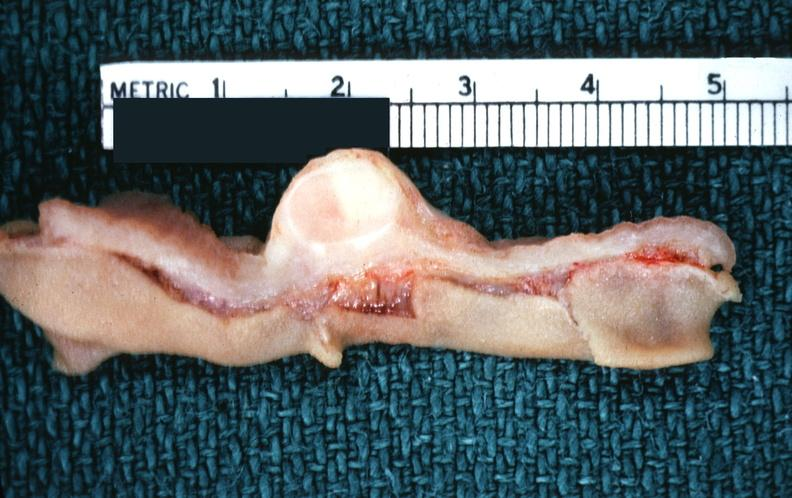s gastrointestinal present?
Answer the question using a single word or phrase. Yes 